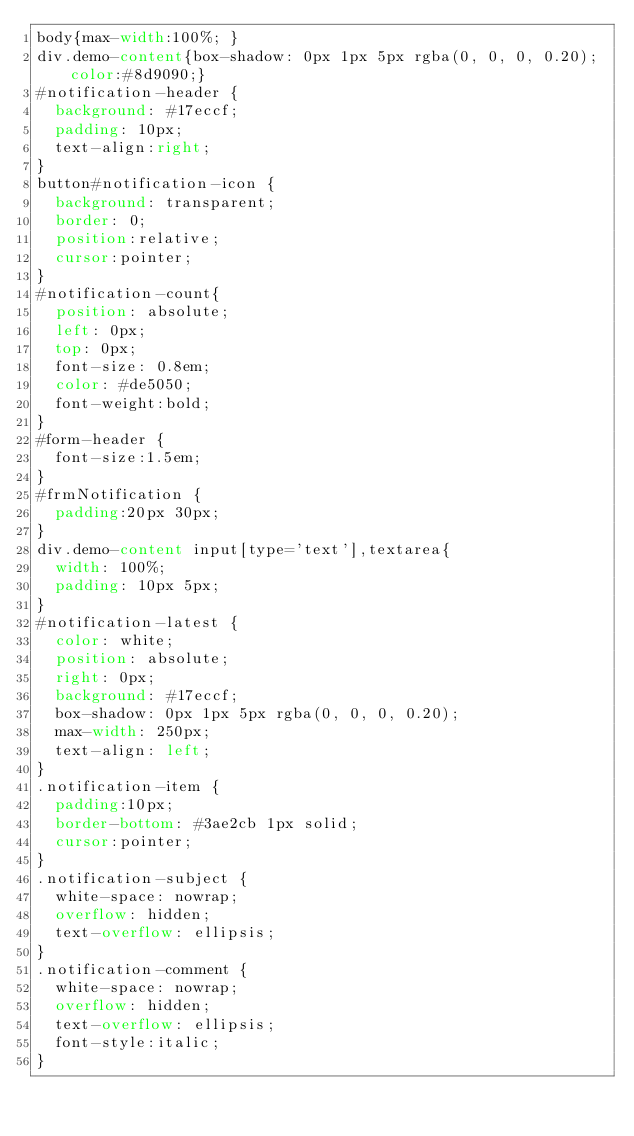<code> <loc_0><loc_0><loc_500><loc_500><_CSS_>body{max-width:100%; }
div.demo-content{box-shadow: 0px 1px 5px rgba(0, 0, 0, 0.20);color:#8d9090;}
#notification-header {
	background: #17eccf;
	padding: 10px;
	text-align:right;
}
button#notification-icon {
	background: transparent;
	border: 0;
	position:relative;
	cursor:pointer;
}
#notification-count{
	position: absolute;
	left: 0px;
	top: 0px;
	font-size: 0.8em;		
	color: #de5050;
	font-weight:bold;
}
#form-header {
	font-size:1.5em;
}
#frmNotification {
	padding:20px 30px;
}
div.demo-content input[type='text'],textarea{
	width: 100%;
	padding: 10px 5px;
}
#notification-latest {
	color: white;
	position: absolute;
	right: 0px;
	background: #17eccf;
	box-shadow: 0px 1px 5px rgba(0, 0, 0, 0.20);		
	max-width: 250px;
	text-align: left;
}
.notification-item {
	padding:10px;
	border-bottom: #3ae2cb 1px solid;
	cursor:pointer;
}
.notification-subject {		
  white-space: nowrap;
  overflow: hidden;
  text-overflow: ellipsis;
}
.notification-comment {		
  white-space: nowrap;
  overflow: hidden;
  text-overflow: ellipsis;
  font-style:italic;
}</code> 